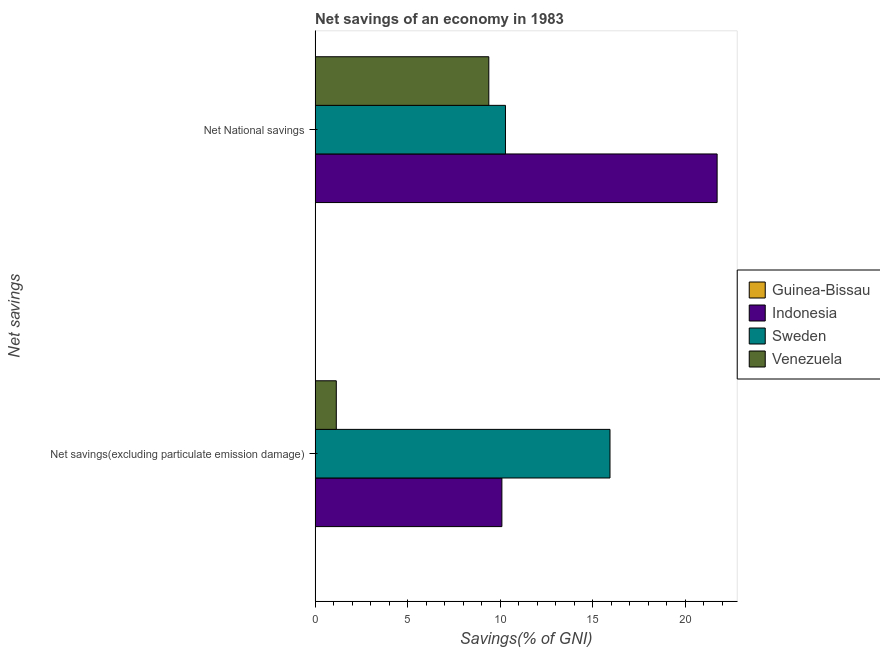How many bars are there on the 1st tick from the top?
Make the answer very short. 3. What is the label of the 1st group of bars from the top?
Your answer should be very brief. Net National savings. What is the net savings(excluding particulate emission damage) in Venezuela?
Make the answer very short. 1.15. Across all countries, what is the maximum net national savings?
Ensure brevity in your answer.  21.72. Across all countries, what is the minimum net national savings?
Give a very brief answer. 0. In which country was the net national savings maximum?
Your answer should be very brief. Indonesia. What is the total net savings(excluding particulate emission damage) in the graph?
Ensure brevity in your answer.  27.17. What is the difference between the net national savings in Indonesia and that in Venezuela?
Offer a terse response. 12.34. What is the difference between the net savings(excluding particulate emission damage) in Indonesia and the net national savings in Sweden?
Provide a short and direct response. -0.19. What is the average net savings(excluding particulate emission damage) per country?
Offer a very short reply. 6.79. What is the difference between the net savings(excluding particulate emission damage) and net national savings in Venezuela?
Make the answer very short. -8.24. What is the ratio of the net national savings in Sweden to that in Indonesia?
Keep it short and to the point. 0.47. Is the net savings(excluding particulate emission damage) in Indonesia less than that in Sweden?
Offer a terse response. Yes. Are all the bars in the graph horizontal?
Your answer should be very brief. Yes. How many countries are there in the graph?
Offer a very short reply. 4. Are the values on the major ticks of X-axis written in scientific E-notation?
Ensure brevity in your answer.  No. Does the graph contain any zero values?
Your answer should be very brief. Yes. Where does the legend appear in the graph?
Make the answer very short. Center right. What is the title of the graph?
Ensure brevity in your answer.  Net savings of an economy in 1983. What is the label or title of the X-axis?
Offer a very short reply. Savings(% of GNI). What is the label or title of the Y-axis?
Offer a terse response. Net savings. What is the Savings(% of GNI) of Indonesia in Net savings(excluding particulate emission damage)?
Make the answer very short. 10.09. What is the Savings(% of GNI) in Sweden in Net savings(excluding particulate emission damage)?
Your response must be concise. 15.93. What is the Savings(% of GNI) in Venezuela in Net savings(excluding particulate emission damage)?
Give a very brief answer. 1.15. What is the Savings(% of GNI) in Indonesia in Net National savings?
Provide a succinct answer. 21.72. What is the Savings(% of GNI) in Sweden in Net National savings?
Your response must be concise. 10.29. What is the Savings(% of GNI) of Venezuela in Net National savings?
Give a very brief answer. 9.39. Across all Net savings, what is the maximum Savings(% of GNI) in Indonesia?
Provide a short and direct response. 21.72. Across all Net savings, what is the maximum Savings(% of GNI) in Sweden?
Your answer should be very brief. 15.93. Across all Net savings, what is the maximum Savings(% of GNI) in Venezuela?
Your response must be concise. 9.39. Across all Net savings, what is the minimum Savings(% of GNI) of Indonesia?
Give a very brief answer. 10.09. Across all Net savings, what is the minimum Savings(% of GNI) of Sweden?
Offer a very short reply. 10.29. Across all Net savings, what is the minimum Savings(% of GNI) in Venezuela?
Your answer should be compact. 1.15. What is the total Savings(% of GNI) in Guinea-Bissau in the graph?
Your answer should be very brief. 0. What is the total Savings(% of GNI) in Indonesia in the graph?
Keep it short and to the point. 31.81. What is the total Savings(% of GNI) in Sweden in the graph?
Keep it short and to the point. 26.22. What is the total Savings(% of GNI) of Venezuela in the graph?
Your answer should be compact. 10.53. What is the difference between the Savings(% of GNI) of Indonesia in Net savings(excluding particulate emission damage) and that in Net National savings?
Provide a succinct answer. -11.63. What is the difference between the Savings(% of GNI) in Sweden in Net savings(excluding particulate emission damage) and that in Net National savings?
Keep it short and to the point. 5.65. What is the difference between the Savings(% of GNI) of Venezuela in Net savings(excluding particulate emission damage) and that in Net National savings?
Your response must be concise. -8.24. What is the difference between the Savings(% of GNI) in Indonesia in Net savings(excluding particulate emission damage) and the Savings(% of GNI) in Sweden in Net National savings?
Provide a succinct answer. -0.19. What is the difference between the Savings(% of GNI) of Indonesia in Net savings(excluding particulate emission damage) and the Savings(% of GNI) of Venezuela in Net National savings?
Provide a short and direct response. 0.71. What is the difference between the Savings(% of GNI) of Sweden in Net savings(excluding particulate emission damage) and the Savings(% of GNI) of Venezuela in Net National savings?
Give a very brief answer. 6.55. What is the average Savings(% of GNI) in Guinea-Bissau per Net savings?
Give a very brief answer. 0. What is the average Savings(% of GNI) in Indonesia per Net savings?
Give a very brief answer. 15.91. What is the average Savings(% of GNI) of Sweden per Net savings?
Provide a short and direct response. 13.11. What is the average Savings(% of GNI) of Venezuela per Net savings?
Offer a very short reply. 5.27. What is the difference between the Savings(% of GNI) in Indonesia and Savings(% of GNI) in Sweden in Net savings(excluding particulate emission damage)?
Your answer should be compact. -5.84. What is the difference between the Savings(% of GNI) of Indonesia and Savings(% of GNI) of Venezuela in Net savings(excluding particulate emission damage)?
Offer a very short reply. 8.95. What is the difference between the Savings(% of GNI) in Sweden and Savings(% of GNI) in Venezuela in Net savings(excluding particulate emission damage)?
Ensure brevity in your answer.  14.79. What is the difference between the Savings(% of GNI) in Indonesia and Savings(% of GNI) in Sweden in Net National savings?
Keep it short and to the point. 11.44. What is the difference between the Savings(% of GNI) of Indonesia and Savings(% of GNI) of Venezuela in Net National savings?
Ensure brevity in your answer.  12.34. What is the ratio of the Savings(% of GNI) in Indonesia in Net savings(excluding particulate emission damage) to that in Net National savings?
Your response must be concise. 0.46. What is the ratio of the Savings(% of GNI) of Sweden in Net savings(excluding particulate emission damage) to that in Net National savings?
Your response must be concise. 1.55. What is the ratio of the Savings(% of GNI) in Venezuela in Net savings(excluding particulate emission damage) to that in Net National savings?
Give a very brief answer. 0.12. What is the difference between the highest and the second highest Savings(% of GNI) in Indonesia?
Give a very brief answer. 11.63. What is the difference between the highest and the second highest Savings(% of GNI) in Sweden?
Offer a very short reply. 5.65. What is the difference between the highest and the second highest Savings(% of GNI) of Venezuela?
Offer a terse response. 8.24. What is the difference between the highest and the lowest Savings(% of GNI) of Indonesia?
Provide a short and direct response. 11.63. What is the difference between the highest and the lowest Savings(% of GNI) of Sweden?
Your answer should be compact. 5.65. What is the difference between the highest and the lowest Savings(% of GNI) of Venezuela?
Your answer should be compact. 8.24. 